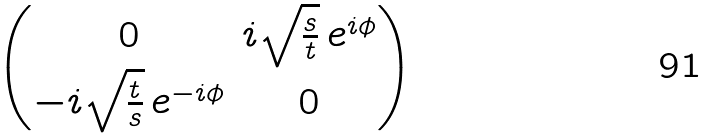<formula> <loc_0><loc_0><loc_500><loc_500>\begin{pmatrix} 0 & i \sqrt { \frac { s } { t } } \, e ^ { i \phi } \\ - i \sqrt { \frac { t } { s } } \, e ^ { - i \phi } & 0 \end{pmatrix}</formula> 